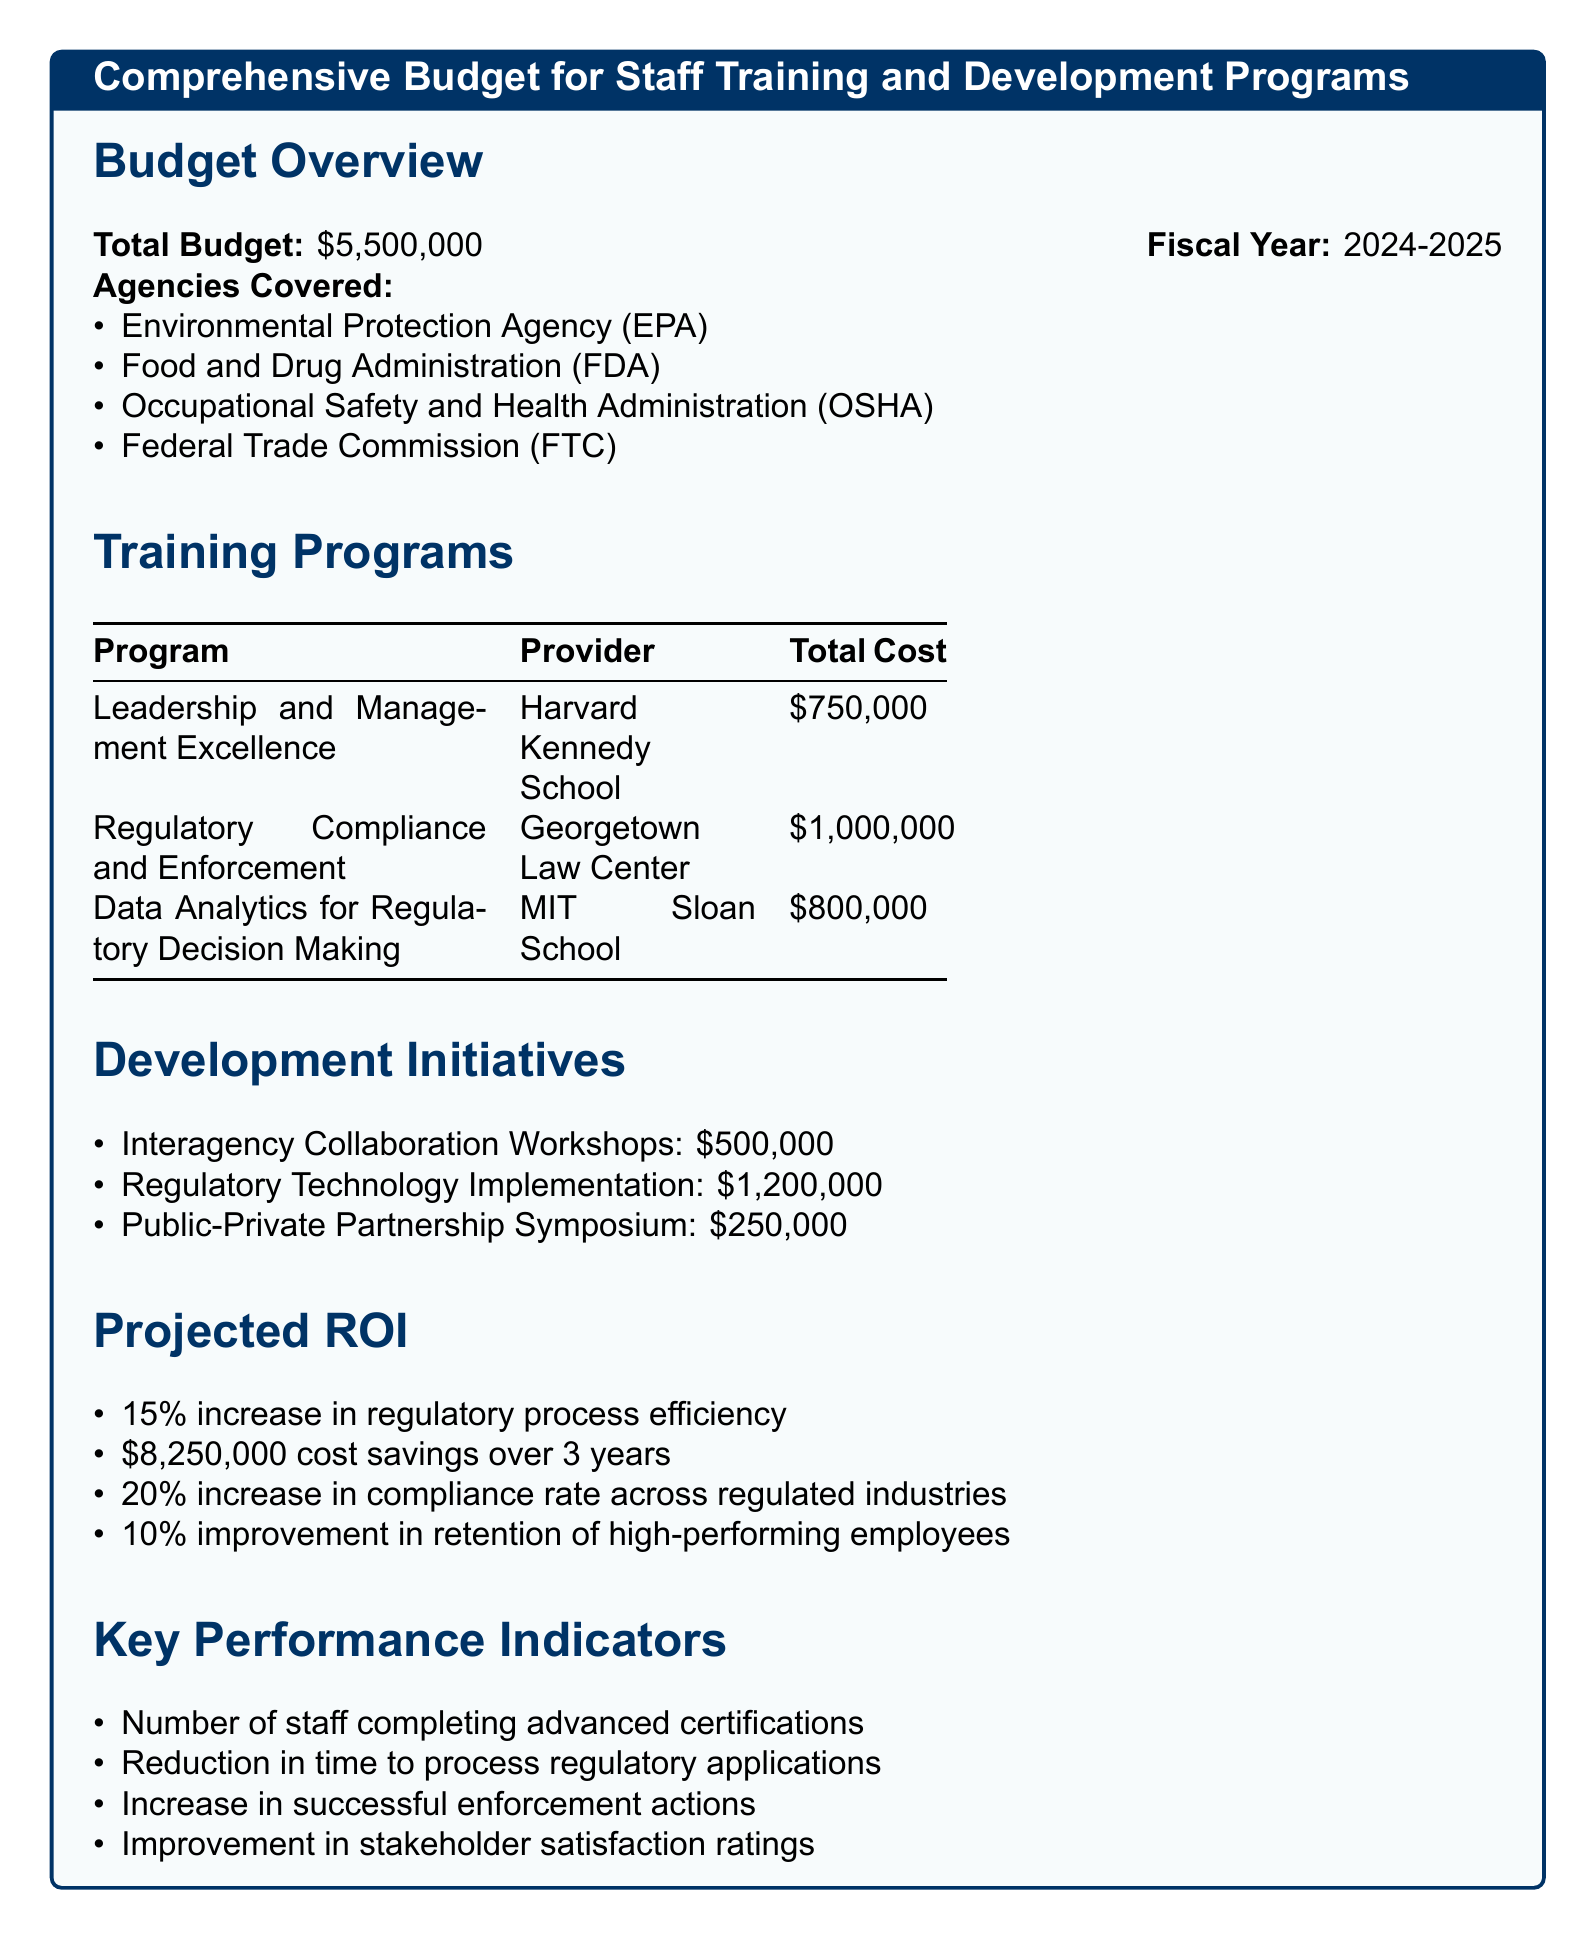What is the total budget for staff training and development programs? The total budget is stated in the document as $5,500,000.
Answer: $5,500,000 Which agencies are covered by the budget? The document lists four regulatory agencies that are included in the budget.
Answer: EPA, FDA, OSHA, FTC What is the cost of the Leadership and Management Excellence program? The cost for the specific training program is provided in the table of training programs.
Answer: $750,000 What is the projected increase in regulatory process efficiency? The document specifies the expected percentage increase in regulatory efficiency as a result of the training programs.
Answer: 15% How much is allocated for Regulatory Technology Implementation? The document lists the individual costs for various development initiatives, including this one.
Answer: $1,200,000 What is the projected cost savings over 3 years? The document states the amount of cost savings expected as a result of the training and development programs.
Answer: $8,250,000 What improvement is expected in retention of high-performing employees? The projected improvement in employee retention is mentioned in the section on projected ROI.
Answer: 10% What key performance indicator relates to stakeholder satisfaction? The document outlines key performance indicators, including one that pertains to stakeholder satisfaction ratings.
Answer: Improvement in stakeholder satisfaction ratings What is the total cost of the training programs listed? The total cost can be calculated by adding the individual program costs listed in the table.
Answer: $2,550,000 